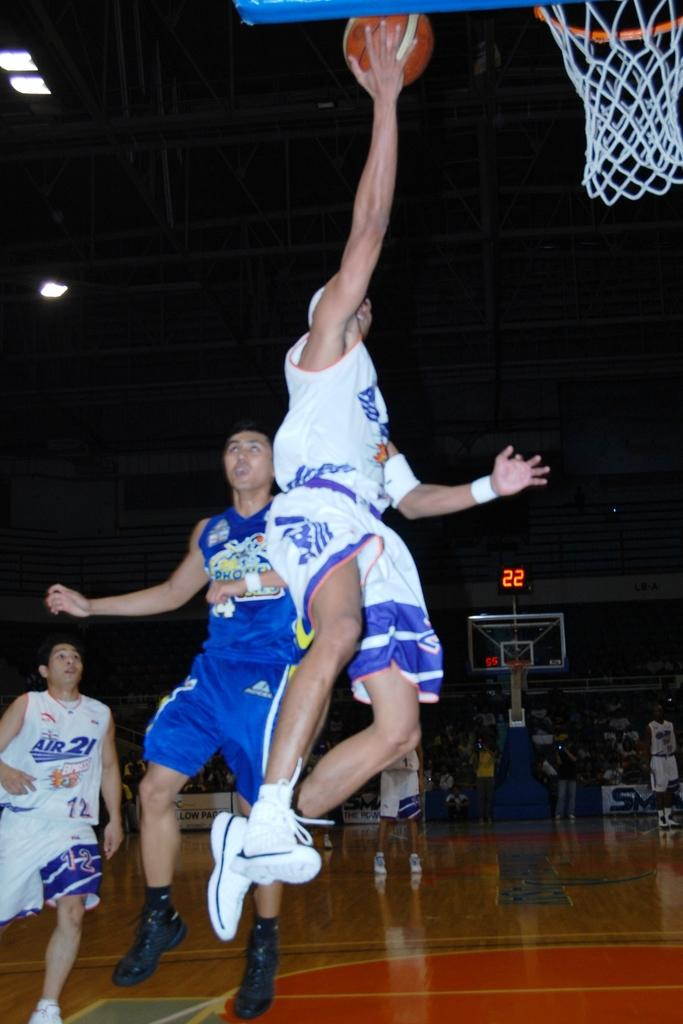<image>
Describe the image concisely. a basketball player going up for a shot while his teammate number 21 looks on 